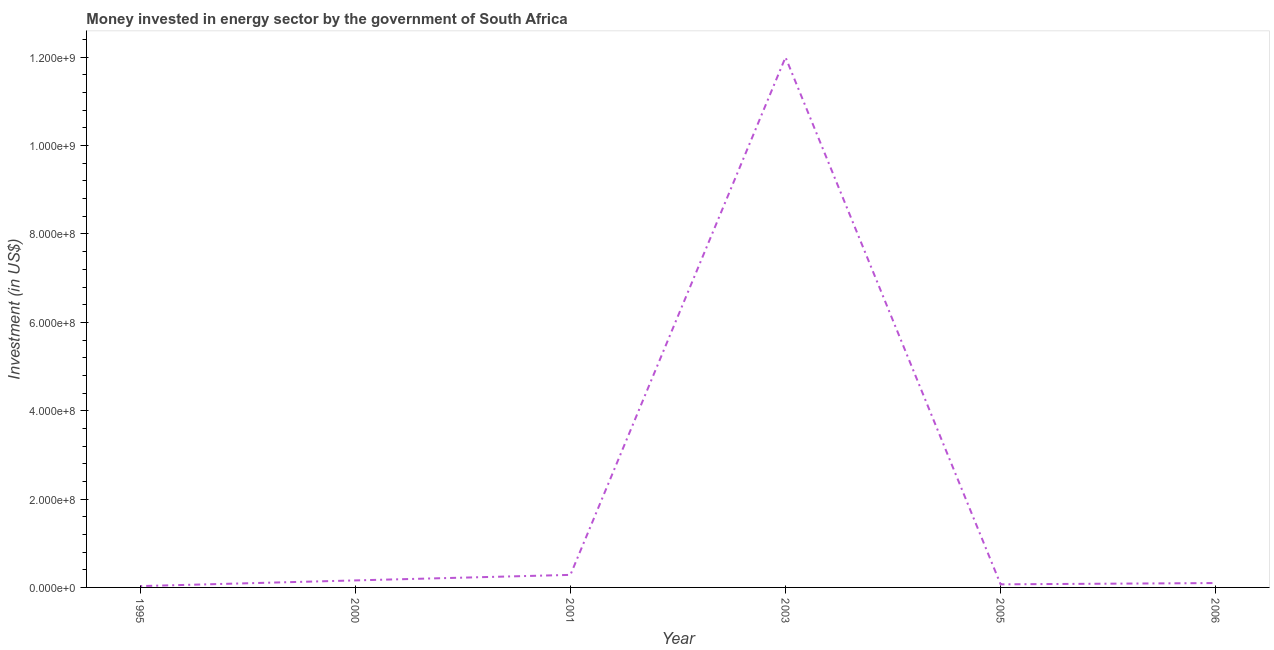What is the investment in energy in 2005?
Make the answer very short. 7.00e+06. Across all years, what is the maximum investment in energy?
Provide a short and direct response. 1.20e+09. Across all years, what is the minimum investment in energy?
Your answer should be compact. 3.00e+06. In which year was the investment in energy maximum?
Offer a terse response. 2003. What is the sum of the investment in energy?
Your response must be concise. 1.26e+09. What is the difference between the investment in energy in 2001 and 2005?
Make the answer very short. 2.14e+07. What is the average investment in energy per year?
Make the answer very short. 2.11e+08. What is the median investment in energy?
Offer a very short reply. 1.29e+07. Do a majority of the years between 2006 and 2000 (inclusive) have investment in energy greater than 200000000 US$?
Offer a terse response. Yes. What is the ratio of the investment in energy in 1995 to that in 2005?
Your answer should be very brief. 0.43. Is the investment in energy in 1995 less than that in 2005?
Offer a terse response. Yes. Is the difference between the investment in energy in 2003 and 2005 greater than the difference between any two years?
Your answer should be compact. No. What is the difference between the highest and the second highest investment in energy?
Your answer should be compact. 1.17e+09. What is the difference between the highest and the lowest investment in energy?
Offer a terse response. 1.20e+09. Does the investment in energy monotonically increase over the years?
Make the answer very short. No. How many lines are there?
Provide a succinct answer. 1. Are the values on the major ticks of Y-axis written in scientific E-notation?
Offer a terse response. Yes. Does the graph contain any zero values?
Ensure brevity in your answer.  No. What is the title of the graph?
Provide a succinct answer. Money invested in energy sector by the government of South Africa. What is the label or title of the X-axis?
Offer a terse response. Year. What is the label or title of the Y-axis?
Make the answer very short. Investment (in US$). What is the Investment (in US$) in 1995?
Give a very brief answer. 3.00e+06. What is the Investment (in US$) of 2000?
Ensure brevity in your answer.  1.59e+07. What is the Investment (in US$) in 2001?
Offer a terse response. 2.84e+07. What is the Investment (in US$) of 2003?
Ensure brevity in your answer.  1.20e+09. What is the Investment (in US$) in 2006?
Offer a very short reply. 9.90e+06. What is the difference between the Investment (in US$) in 1995 and 2000?
Offer a terse response. -1.29e+07. What is the difference between the Investment (in US$) in 1995 and 2001?
Offer a very short reply. -2.54e+07. What is the difference between the Investment (in US$) in 1995 and 2003?
Your answer should be compact. -1.20e+09. What is the difference between the Investment (in US$) in 1995 and 2005?
Provide a succinct answer. -4.00e+06. What is the difference between the Investment (in US$) in 1995 and 2006?
Offer a very short reply. -6.90e+06. What is the difference between the Investment (in US$) in 2000 and 2001?
Make the answer very short. -1.25e+07. What is the difference between the Investment (in US$) in 2000 and 2003?
Your answer should be very brief. -1.18e+09. What is the difference between the Investment (in US$) in 2000 and 2005?
Your answer should be compact. 8.90e+06. What is the difference between the Investment (in US$) in 2000 and 2006?
Ensure brevity in your answer.  6.00e+06. What is the difference between the Investment (in US$) in 2001 and 2003?
Offer a terse response. -1.17e+09. What is the difference between the Investment (in US$) in 2001 and 2005?
Your response must be concise. 2.14e+07. What is the difference between the Investment (in US$) in 2001 and 2006?
Your response must be concise. 1.85e+07. What is the difference between the Investment (in US$) in 2003 and 2005?
Your answer should be compact. 1.19e+09. What is the difference between the Investment (in US$) in 2003 and 2006?
Keep it short and to the point. 1.19e+09. What is the difference between the Investment (in US$) in 2005 and 2006?
Offer a very short reply. -2.90e+06. What is the ratio of the Investment (in US$) in 1995 to that in 2000?
Your response must be concise. 0.19. What is the ratio of the Investment (in US$) in 1995 to that in 2001?
Provide a short and direct response. 0.11. What is the ratio of the Investment (in US$) in 1995 to that in 2003?
Your answer should be very brief. 0. What is the ratio of the Investment (in US$) in 1995 to that in 2005?
Keep it short and to the point. 0.43. What is the ratio of the Investment (in US$) in 1995 to that in 2006?
Your response must be concise. 0.3. What is the ratio of the Investment (in US$) in 2000 to that in 2001?
Provide a succinct answer. 0.56. What is the ratio of the Investment (in US$) in 2000 to that in 2003?
Offer a terse response. 0.01. What is the ratio of the Investment (in US$) in 2000 to that in 2005?
Make the answer very short. 2.27. What is the ratio of the Investment (in US$) in 2000 to that in 2006?
Give a very brief answer. 1.61. What is the ratio of the Investment (in US$) in 2001 to that in 2003?
Provide a short and direct response. 0.02. What is the ratio of the Investment (in US$) in 2001 to that in 2005?
Your answer should be very brief. 4.06. What is the ratio of the Investment (in US$) in 2001 to that in 2006?
Your answer should be compact. 2.87. What is the ratio of the Investment (in US$) in 2003 to that in 2005?
Your answer should be very brief. 171.43. What is the ratio of the Investment (in US$) in 2003 to that in 2006?
Keep it short and to the point. 121.21. What is the ratio of the Investment (in US$) in 2005 to that in 2006?
Keep it short and to the point. 0.71. 